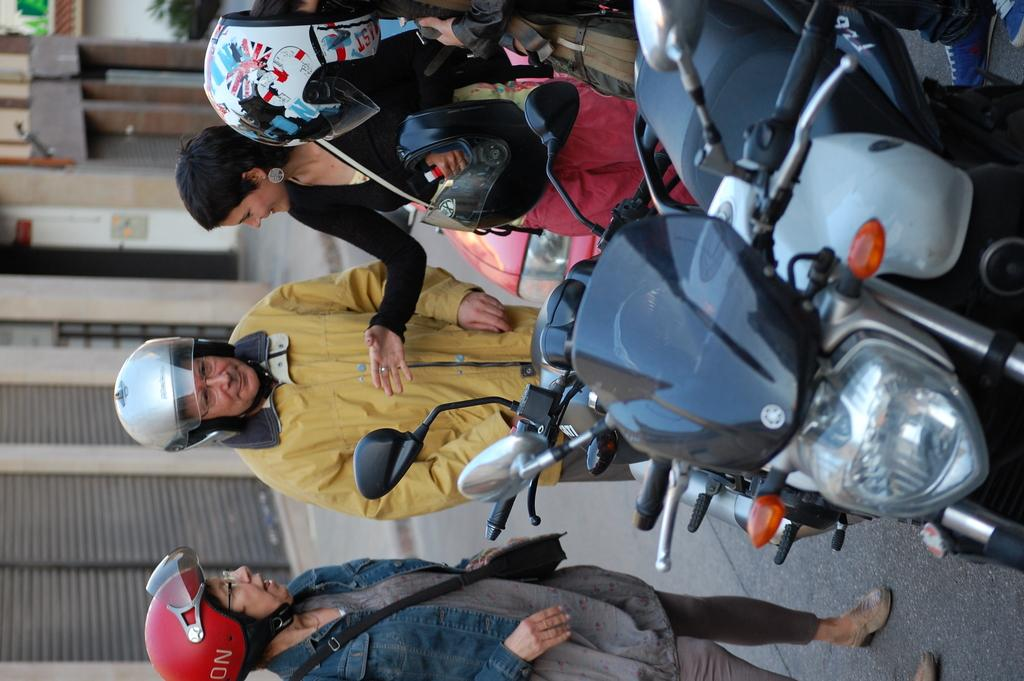What type of vehicles can be seen in the image? There are motorbikes in the image. What safety equipment are the people wearing in the image? People wearing helmets are present in the image. What can be seen on the left side of the image? There are buildings on the left side of the image. How would you describe the clarity of the left side of the image? The left side of the image is blurred. What shape is the cub playing with in the image? There is no cub or any shape present in the image. What scent can be detected from the motorbikes in the image? The image does not provide any information about the scent of the motorbikes. 